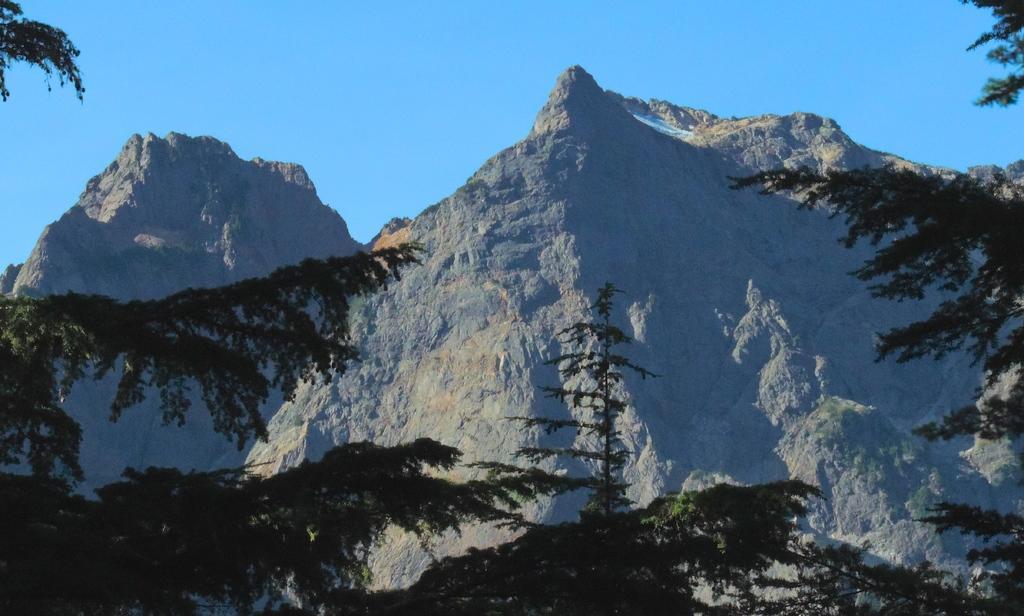Can you describe this image briefly? In Front of the picture there are trees. We can see mountains here and on the background there is a sky. 